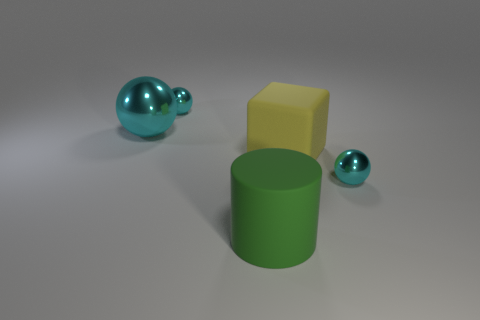Are there any other things that are the same shape as the green rubber object?
Your response must be concise. No. Are the large green cylinder and the cyan sphere that is in front of the big sphere made of the same material?
Your response must be concise. No. There is a metal ball that is right of the green object; is there a tiny shiny thing that is behind it?
Offer a very short reply. Yes. The big object that is behind the big cylinder and on the right side of the large cyan metal ball is what color?
Provide a short and direct response. Yellow. What is the size of the cube?
Keep it short and to the point. Large. What number of yellow blocks have the same size as the green rubber cylinder?
Keep it short and to the point. 1. Does the cyan sphere right of the large block have the same material as the big yellow thing in front of the big metallic thing?
Keep it short and to the point. No. What material is the tiny cyan ball that is behind the cyan metallic object to the right of the yellow thing?
Ensure brevity in your answer.  Metal. There is a cyan sphere behind the large cyan thing; what material is it?
Make the answer very short. Metal. What number of big cyan objects have the same shape as the big yellow matte thing?
Provide a short and direct response. 0. 